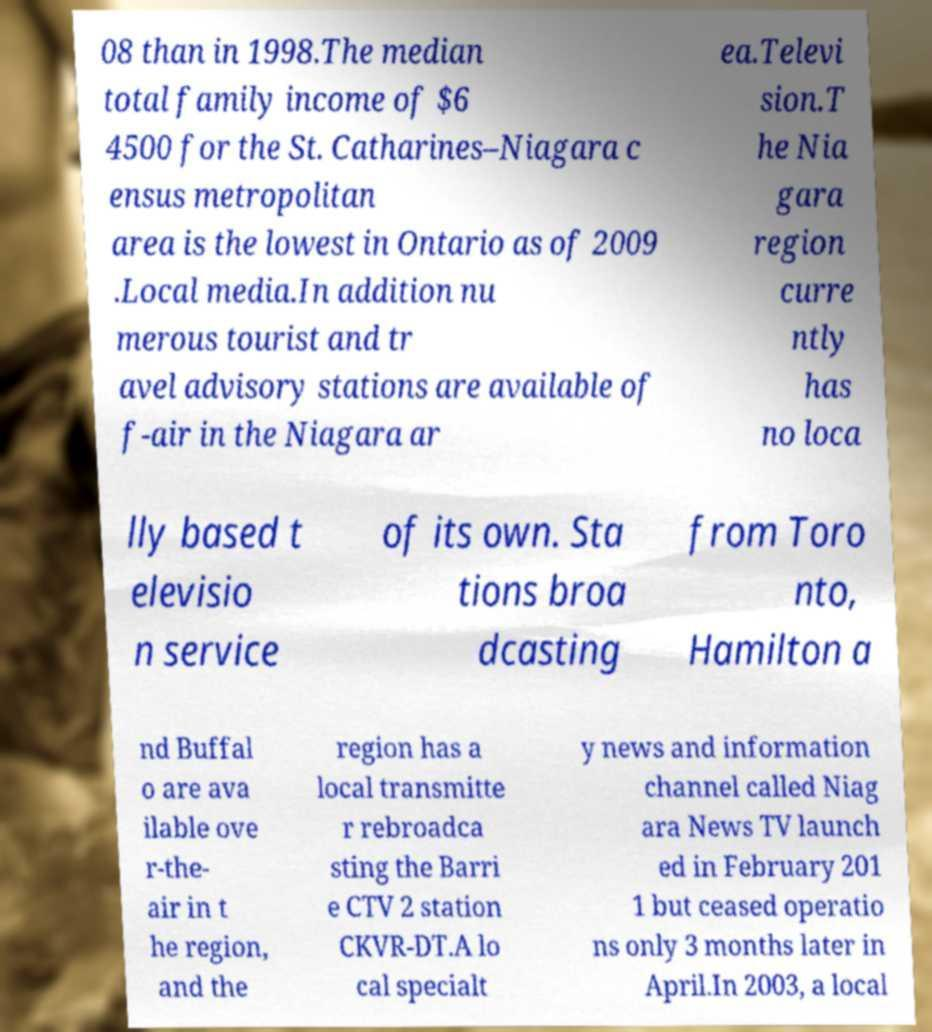Please read and relay the text visible in this image. What does it say? 08 than in 1998.The median total family income of $6 4500 for the St. Catharines–Niagara c ensus metropolitan area is the lowest in Ontario as of 2009 .Local media.In addition nu merous tourist and tr avel advisory stations are available of f-air in the Niagara ar ea.Televi sion.T he Nia gara region curre ntly has no loca lly based t elevisio n service of its own. Sta tions broa dcasting from Toro nto, Hamilton a nd Buffal o are ava ilable ove r-the- air in t he region, and the region has a local transmitte r rebroadca sting the Barri e CTV 2 station CKVR-DT.A lo cal specialt y news and information channel called Niag ara News TV launch ed in February 201 1 but ceased operatio ns only 3 months later in April.In 2003, a local 